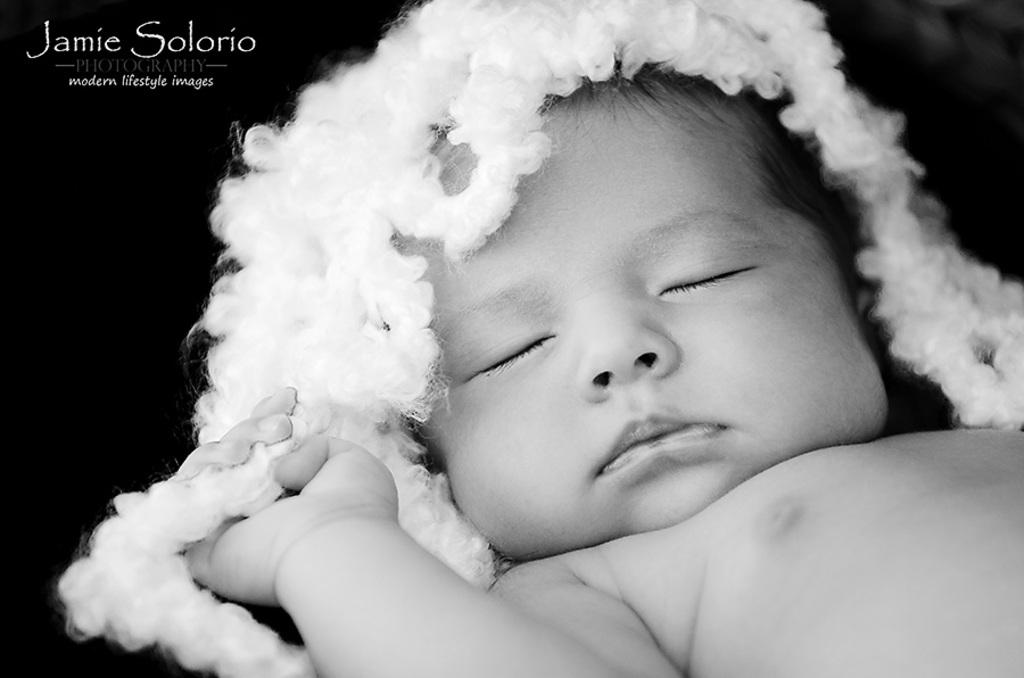What type of picture is in the image? The image contains a black and white picture. Who or what is depicted in the black and white picture? There is a baby in the black and white picture. What color is the object in the black and white picture? The object in the black and white picture is white. What color is the background of the black and white picture? The background of the black and white picture is black. How many arches can be seen in the black and white picture? There are no arches present in the black and white picture; it features a baby and a white object against a black background. 